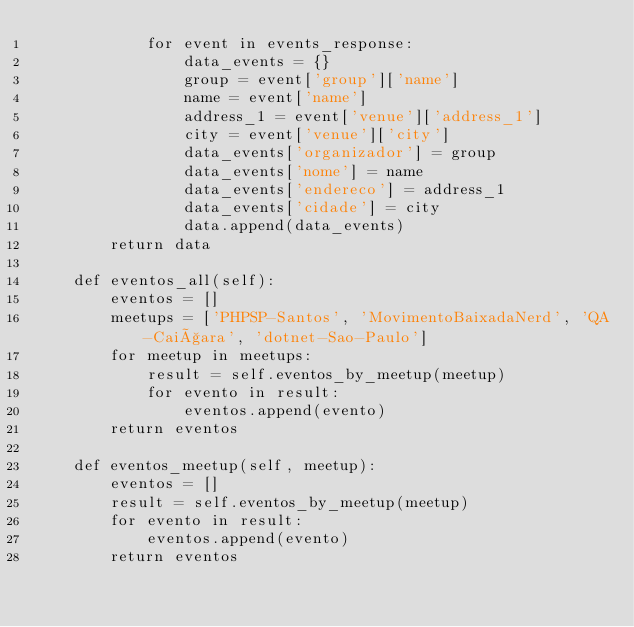Convert code to text. <code><loc_0><loc_0><loc_500><loc_500><_Python_>            for event in events_response:
                data_events = {}
                group = event['group']['name']
                name = event['name']
                address_1 = event['venue']['address_1']
                city = event['venue']['city']
                data_events['organizador'] = group
                data_events['nome'] = name
                data_events['endereco'] = address_1
                data_events['cidade'] = city
                data.append(data_events)
        return data

    def eventos_all(self):
        eventos = []
        meetups = ['PHPSP-Santos', 'MovimentoBaixadaNerd', 'QA-Caiçara', 'dotnet-Sao-Paulo']
        for meetup in meetups:
            result = self.eventos_by_meetup(meetup)
            for evento in result:
                eventos.append(evento)
        return eventos

    def eventos_meetup(self, meetup):
        eventos = []
        result = self.eventos_by_meetup(meetup)
        for evento in result:
            eventos.append(evento)
        return eventos
</code> 